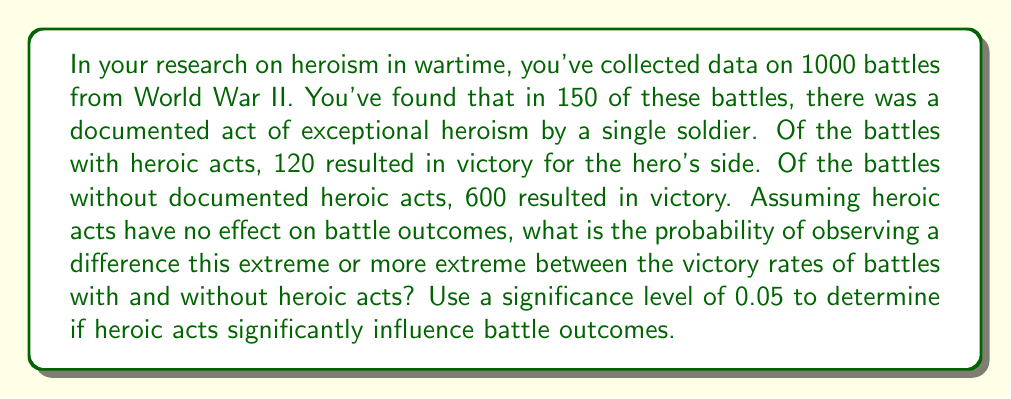Could you help me with this problem? To solve this problem, we'll use a two-proportion z-test to compare the victory rates between battles with and without heroic acts.

Step 1: Define our hypotheses
$H_0$: There is no difference in victory rates between battles with and without heroic acts.
$H_a$: There is a difference in victory rates between battles with and without heroic acts.

Step 2: Calculate the sample proportions
Battles with heroic acts: $p_1 = \frac{120}{150} = 0.8$
Battles without heroic acts: $p_2 = \frac{600}{850} \approx 0.7059$

Step 3: Calculate the pooled proportion
$$p = \frac{120 + 600}{1000} = 0.72$$

Step 4: Calculate the standard error
$$SE = \sqrt{p(1-p)(\frac{1}{150} + \frac{1}{850})} \approx 0.0391$$

Step 5: Calculate the z-score
$$z = \frac{p_1 - p_2}{SE} = \frac{0.8 - 0.7059}{0.0391} \approx 2.4067$$

Step 6: Find the p-value
The p-value for a two-tailed test is:
$$p\text{-value} = 2 \times P(Z > |2.4067|) \approx 0.0161$$

Step 7: Compare the p-value to the significance level
Since 0.0161 < 0.05, we reject the null hypothesis.
Answer: The p-value is approximately 0.0161, which is less than the significance level of 0.05. Therefore, we reject the null hypothesis and conclude that there is statistically significant evidence to suggest that heroic acts influence battle outcomes. 